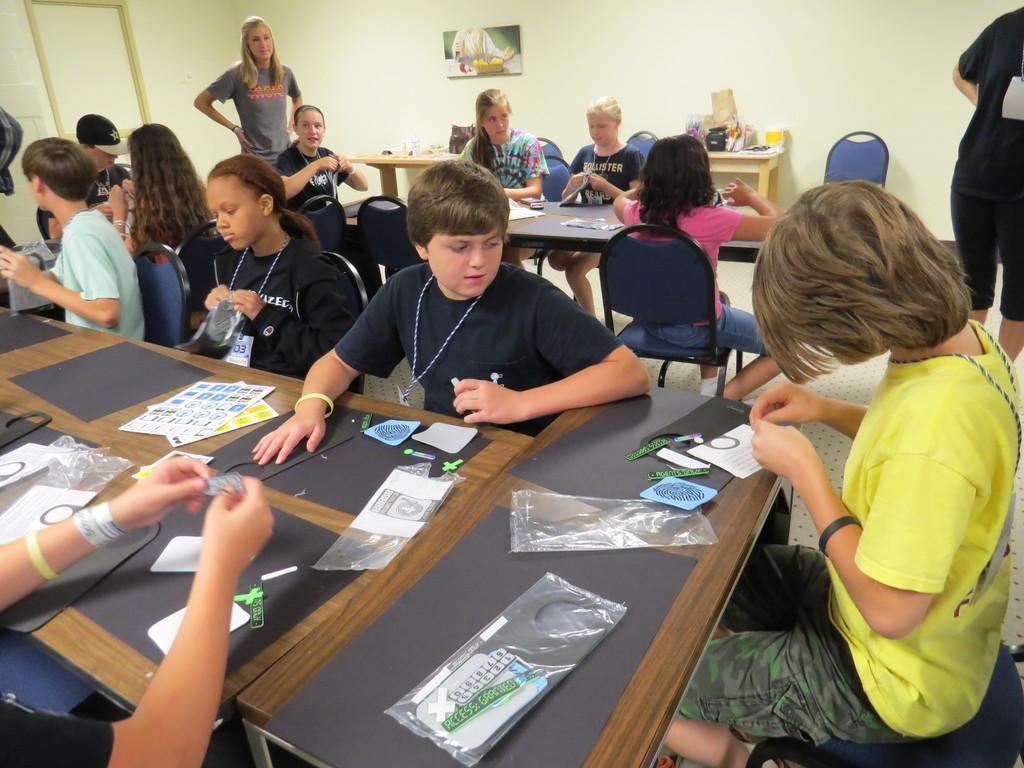Please provide a concise description of this image. In this image, we can see kids sitting on the chairs and they are holding some objects and we can see some objects like papers, chats, covers which are placed on the tables and in the background, there are some other people standing and we can see a frame placed on the wall. At the bottom, there is floor. 